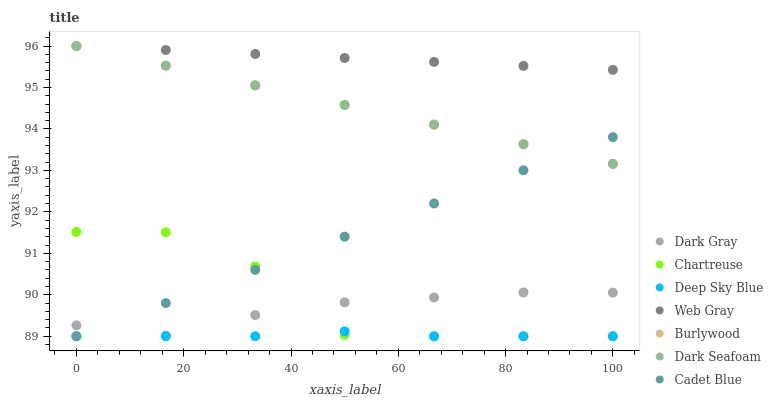Does Deep Sky Blue have the minimum area under the curve?
Answer yes or no. Yes. Does Web Gray have the maximum area under the curve?
Answer yes or no. Yes. Does Burlywood have the minimum area under the curve?
Answer yes or no. No. Does Burlywood have the maximum area under the curve?
Answer yes or no. No. Is Burlywood the smoothest?
Answer yes or no. Yes. Is Chartreuse the roughest?
Answer yes or no. Yes. Is Dark Gray the smoothest?
Answer yes or no. No. Is Dark Gray the roughest?
Answer yes or no. No. Does Chartreuse have the lowest value?
Answer yes or no. Yes. Does Burlywood have the lowest value?
Answer yes or no. No. Does Dark Seafoam have the highest value?
Answer yes or no. Yes. Does Dark Gray have the highest value?
Answer yes or no. No. Is Cadet Blue less than Web Gray?
Answer yes or no. Yes. Is Web Gray greater than Deep Sky Blue?
Answer yes or no. Yes. Does Dark Gray intersect Cadet Blue?
Answer yes or no. Yes. Is Dark Gray less than Cadet Blue?
Answer yes or no. No. Is Dark Gray greater than Cadet Blue?
Answer yes or no. No. Does Cadet Blue intersect Web Gray?
Answer yes or no. No. 